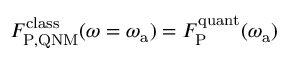Convert formula to latex. <formula><loc_0><loc_0><loc_500><loc_500>F _ { P , Q N M } ^ { c l a s s } ( \omega = \omega _ { a } ) = F _ { P } ^ { q u a n t } ( \omega _ { a } )</formula> 